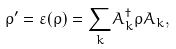Convert formula to latex. <formula><loc_0><loc_0><loc_500><loc_500>\rho ^ { \prime } = \varepsilon ( \rho ) = \underset { k } { \sum } A _ { k } ^ { \dagger } \rho A _ { k } ,</formula> 